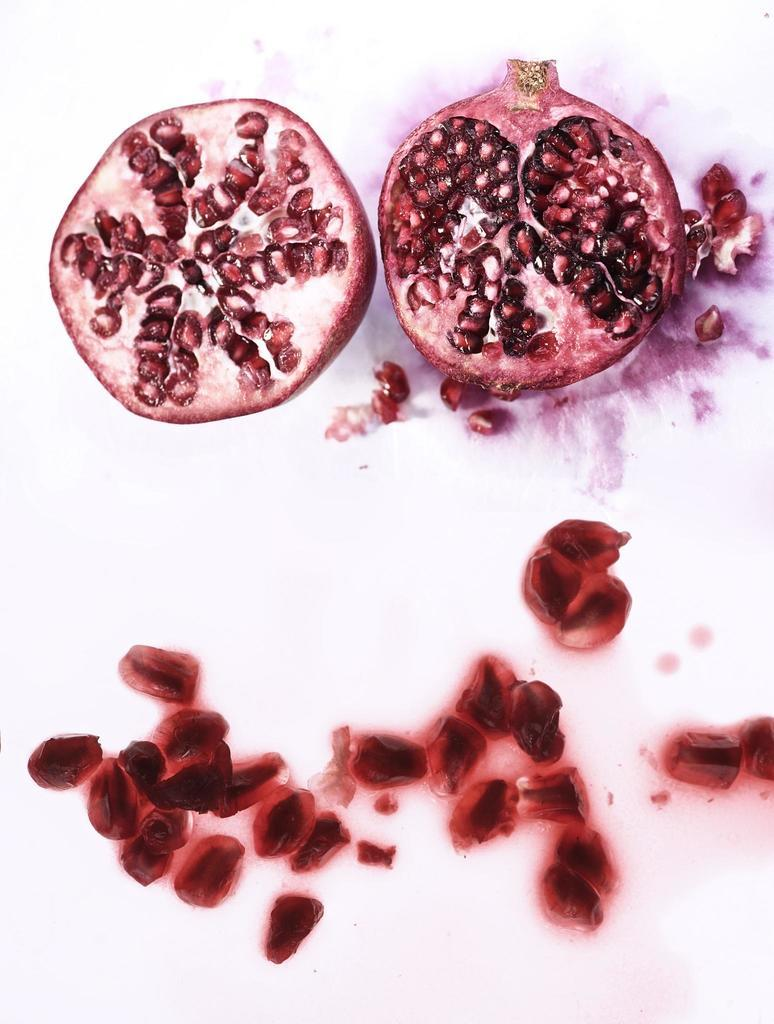What is the main subject of the image? The main subject of the image is a half-cut pomegranate. Where is the pomegranate located in the image? The pomegranate is on a table in the image. What can be seen inside the pomegranate? The seeds of the pomegranate are visible in the image. What type of zephyr is covering the pomegranate in the image? There is no zephyr present in the image; it is a half-cut pomegranate on a table with visible seeds. Is there a veil draped over the pomegranate in the image? No, there is no veil present in the image. 